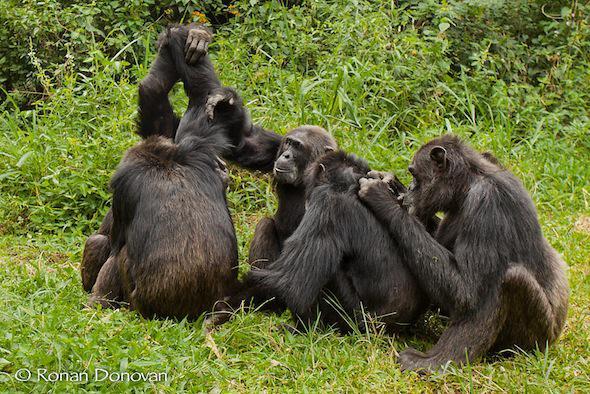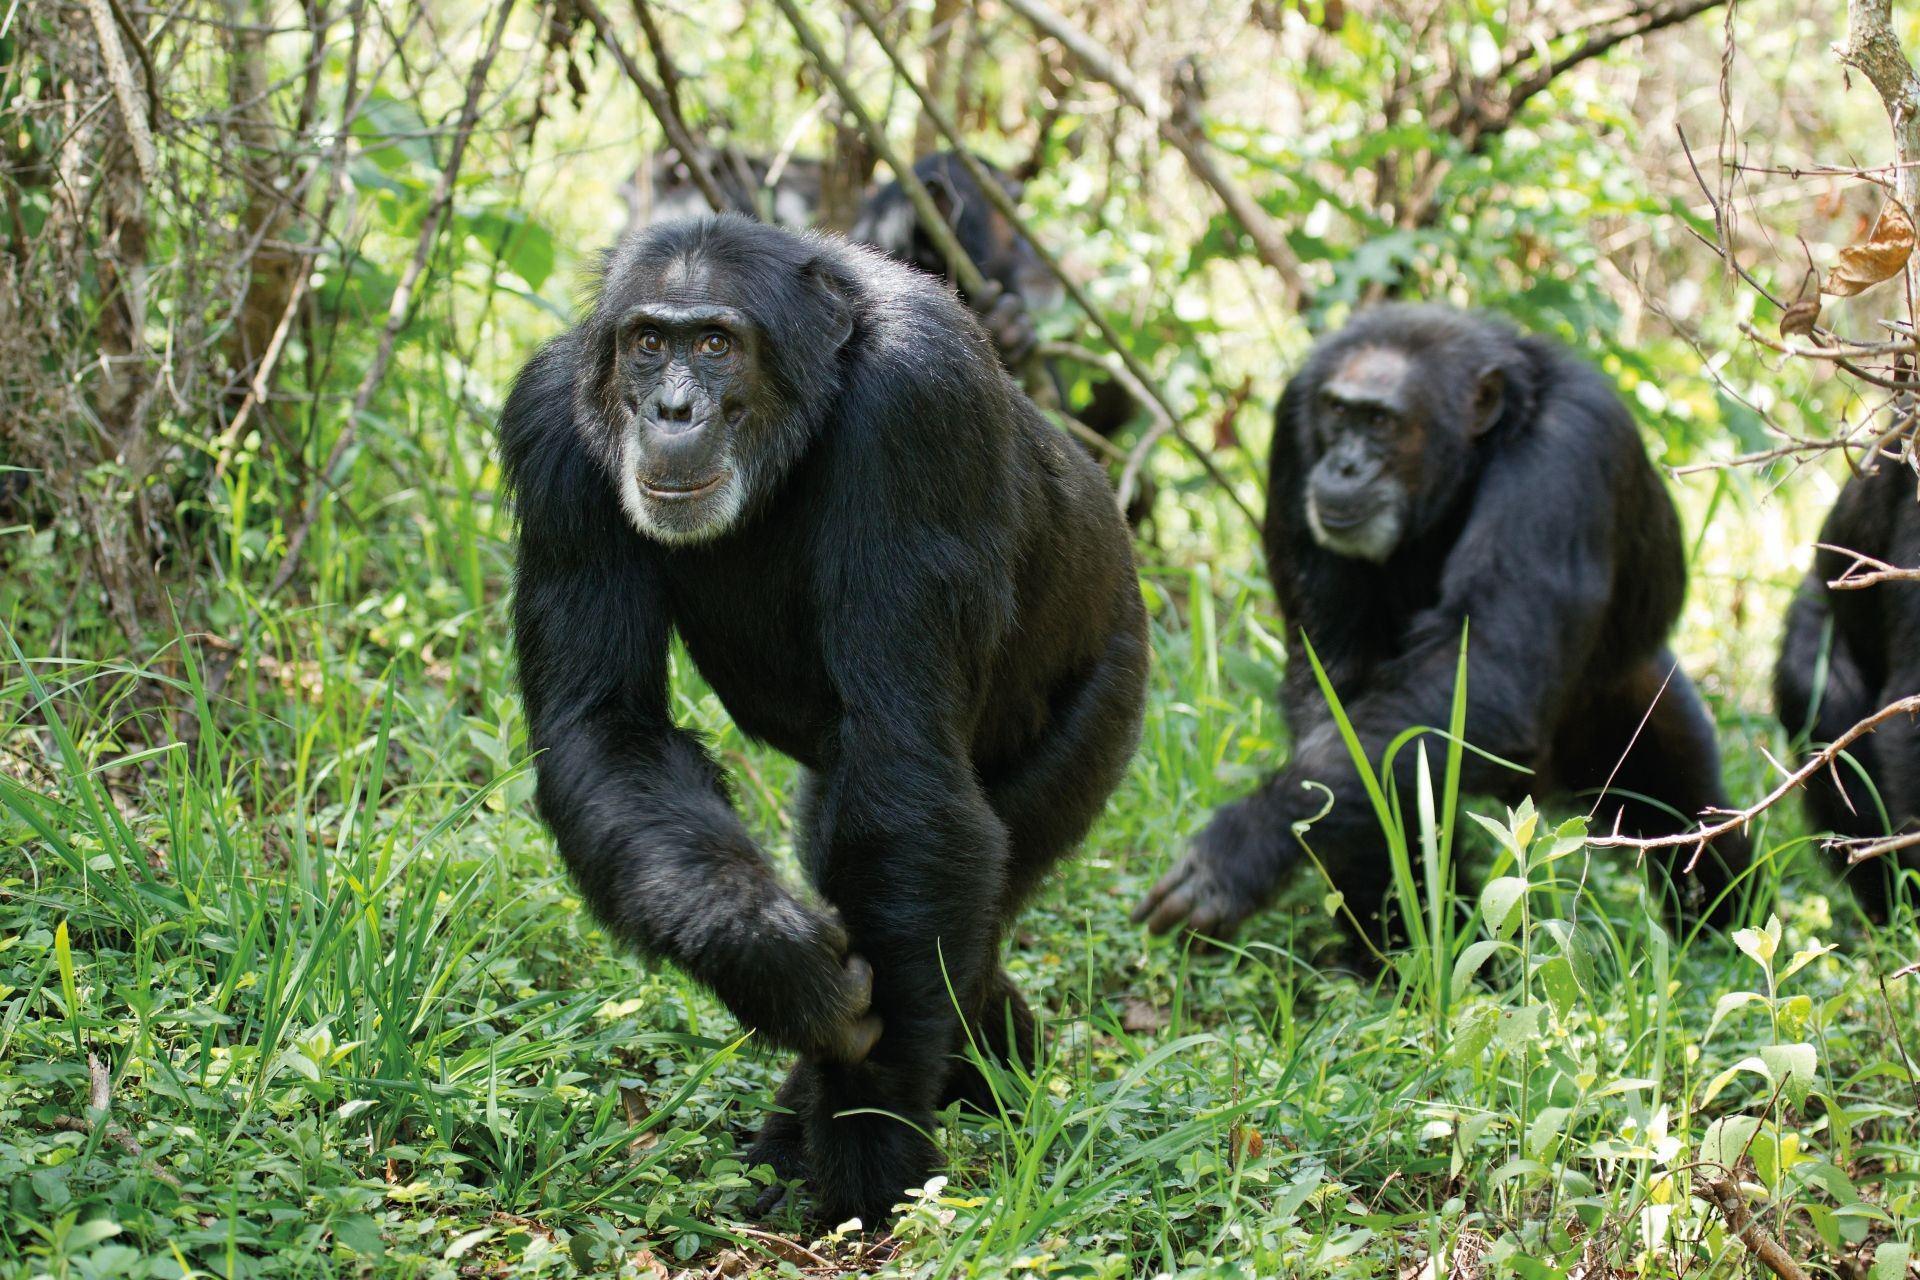The first image is the image on the left, the second image is the image on the right. For the images shown, is this caption "The right image features three apes side by side, all sitting crouched with bent knees." true? Answer yes or no. No. 